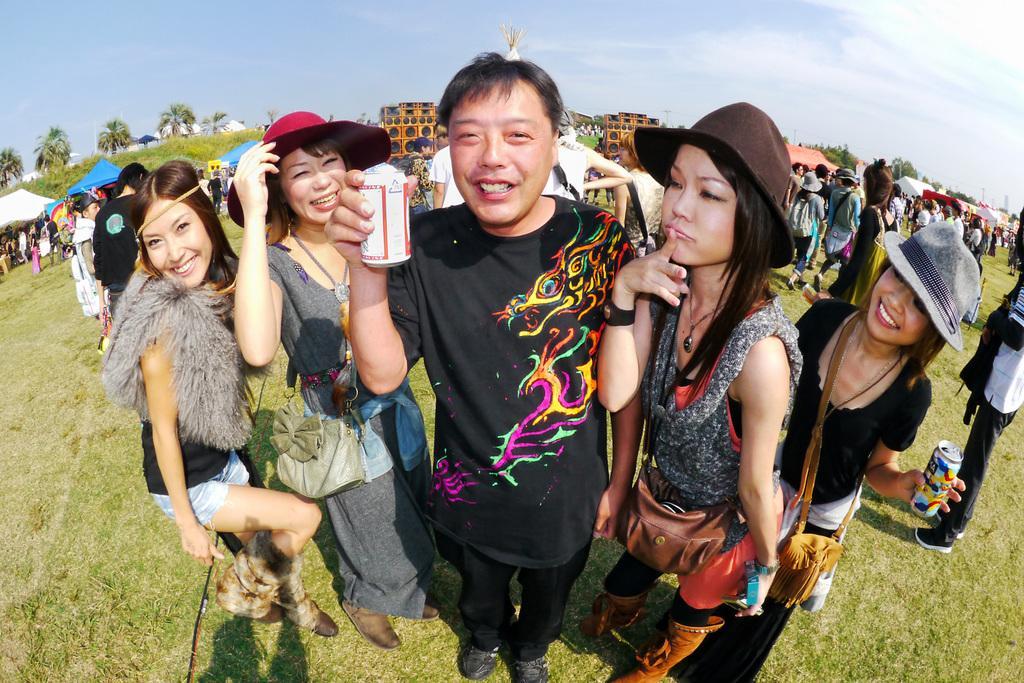Please provide a concise description of this image. In the center of the image we can see a few people are standing. Among them, we can see three persons are wearing hats, two persons are holding some objects and three persons are wearing bags. In the background, we can see the sky, clouds, trees, grass, tents, few people are standing and a few other objects. 